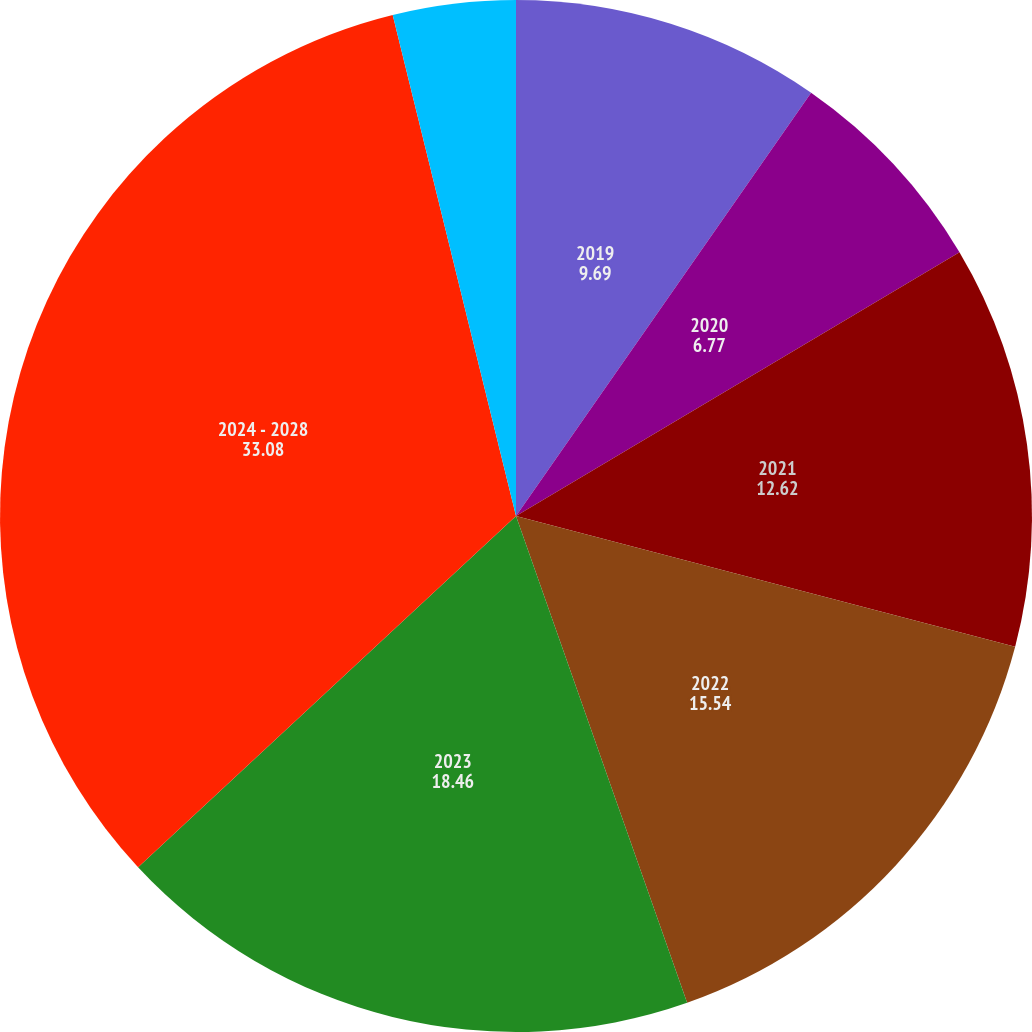Convert chart to OTSL. <chart><loc_0><loc_0><loc_500><loc_500><pie_chart><fcel>2019<fcel>2020<fcel>2021<fcel>2022<fcel>2023<fcel>2024 - 2028<fcel>Required Company Contributions<nl><fcel>9.69%<fcel>6.77%<fcel>12.62%<fcel>15.54%<fcel>18.46%<fcel>33.08%<fcel>3.84%<nl></chart> 